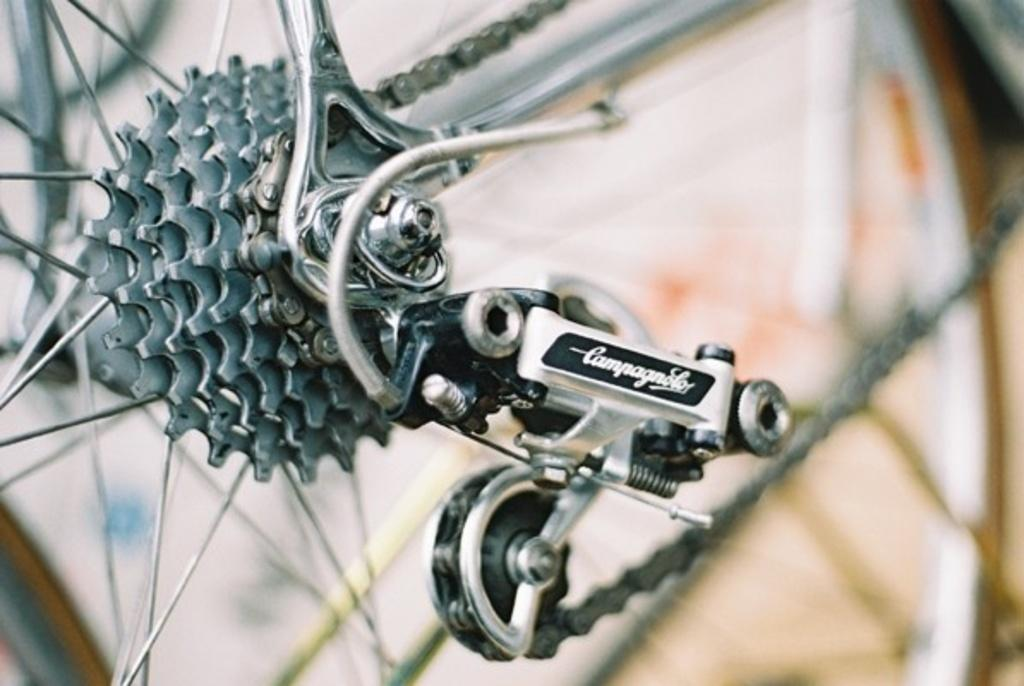What type of vehicle is partially shown in the image? The image shows a part of a vehicle, but it is not specified which type. What can be seen attached to the vehicle? There is a chain visible in the image, attached to the vehicle. What can be seen on the wheels of the vehicle? There are spokes visible in the image, on the wheels of the vehicle. What material is the metal object in the image made of? The metal object in the image is made of metal. What can be read in the image? There is some text visible in the image. Can you describe any other elements in the image? There are other unspecified elements in the image. How many men are standing near the vehicle in the image? There is no mention of men or any people in the image. What is causing the throat irritation in the image? There is no indication of throat irritation or any health-related issues in the image. 